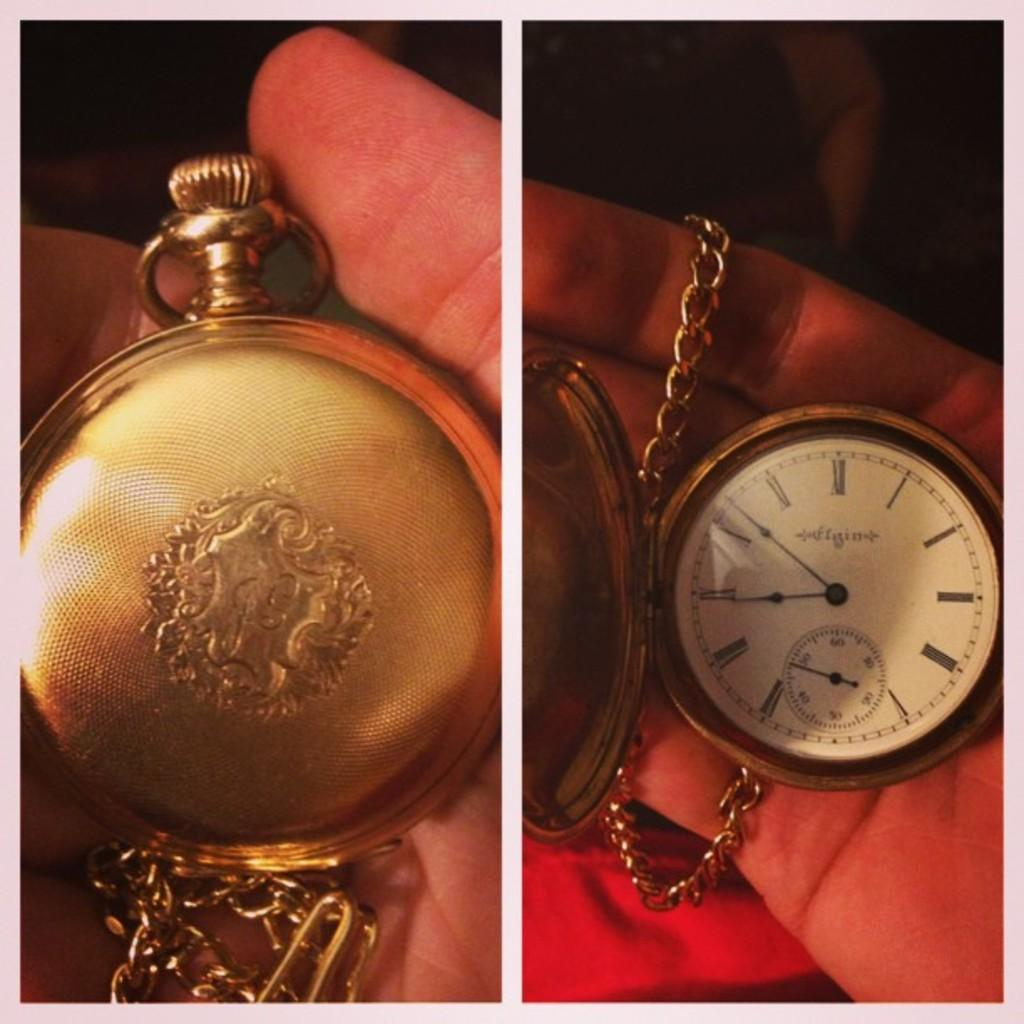<image>
Give a short and clear explanation of the subsequent image. An Elgin pocket watch is displayed both closed and open. 